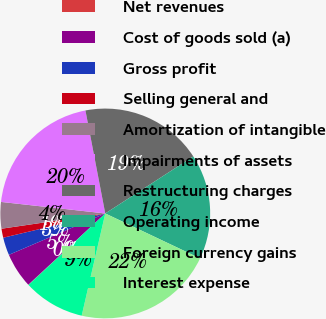<chart> <loc_0><loc_0><loc_500><loc_500><pie_chart><fcel>Net revenues<fcel>Cost of goods sold (a)<fcel>Gross profit<fcel>Selling general and<fcel>Amortization of intangible<fcel>Impairments of assets<fcel>Restructuring charges<fcel>Operating income<fcel>Foreign currency gains<fcel>Interest expense<nl><fcel>0.05%<fcel>5.43%<fcel>2.74%<fcel>1.39%<fcel>4.08%<fcel>20.22%<fcel>18.88%<fcel>16.19%<fcel>21.57%<fcel>9.46%<nl></chart> 